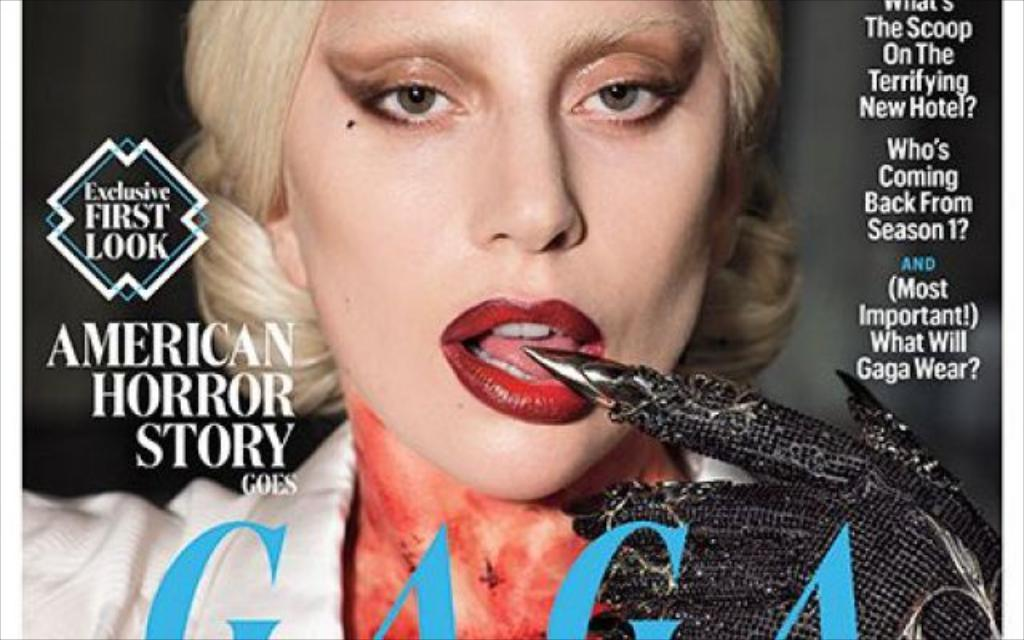Who is depicted on the poster in the image? The poster contains a woman. What is the woman wearing in the image? The woman is wearing a white dress and a black hand glove. What else can be seen on the poster besides the woman? There are letters on the poster. What type of meal is the woman eating in the image? There is no meal present in the image; the woman is not depicted as eating anything. Can you describe the woman's mouth in the image? The image does not provide a close-up view of the woman's mouth, so it cannot be described in detail. 